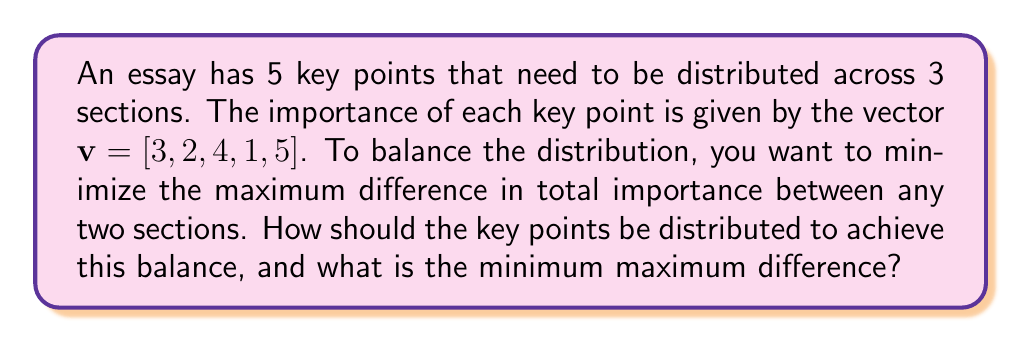Could you help me with this problem? Let's approach this step-by-step:

1) First, we need to consider all possible distributions of 5 key points across 3 sections. This is a partition problem.

2) For each partition, we'll calculate the total importance of each section and find the maximum difference between any two sections.

3) We'll then choose the partition that minimizes this maximum difference.

4) Let's list out some possible partitions and their corresponding importance sums:

   [3,2] [4,1] [5]   : [5, 5, 5]
   [3,2,4] [1] [5]   : [9, 1, 5]
   [3,2,1] [4] [5]   : [6, 4, 5]
   [3,4] [2,1] [5]   : [7, 3, 5]
   [3,1] [2,4] [5]   : [4, 6, 5]
   [2,4,1] [3] [5]   : [7, 3, 5]

5) For each distribution, we calculate the maximum difference:

   [5, 5, 5]   : max difference = 0
   [9, 1, 5]   : max difference = 8
   [6, 4, 5]   : max difference = 2
   [7, 3, 5]   : max difference = 4
   [4, 6, 5]   : max difference = 2
   [7, 3, 5]   : max difference = 4

6) The minimum maximum difference is 0, achieved by the distribution [3,2] [4,1] [5].

This problem is an example of the minimax optimization problem, which is common in various fields including game theory and decision analysis.
Answer: The optimal distribution is [3,2] [4,1] [5], with a minimum maximum difference of 0. 